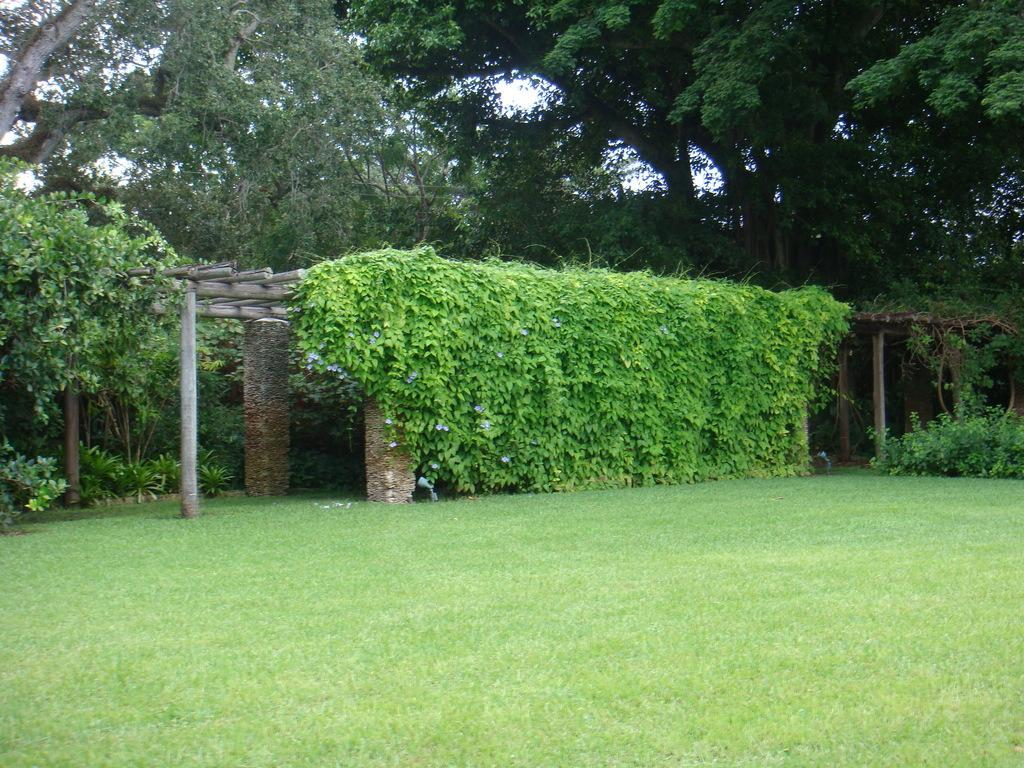What type of structure is depicted in the image? There is a roof with pillars in the image. What is covering the roof? The roof is covered with plants. What type of vegetation can be seen in the image besides the plants on the roof? There is grass and trees visible in the image. What is visible in the background of the image? The sky is visible in the image. Can you see a match being lit in the image? There is no match or any indication of fire in the image. What type of ray is emitted from the trees in the image? There are no rays emitted from the trees in the image; it simply shows trees and other vegetation. 